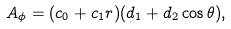Convert formula to latex. <formula><loc_0><loc_0><loc_500><loc_500>A _ { \phi } = ( c _ { 0 } + c _ { 1 } r ) ( d _ { 1 } + d _ { 2 } \cos { \theta } ) ,</formula> 